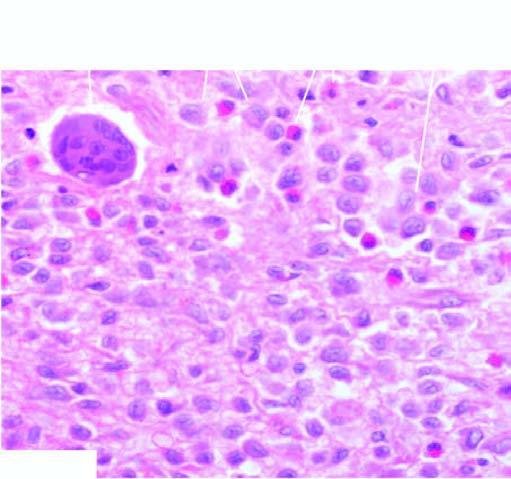how does bone biopsy show?
Answer the question using a single word or phrase. Presence of infiltrate by collections of histiocytes having vesicular nuclei admixed with eosinophils 